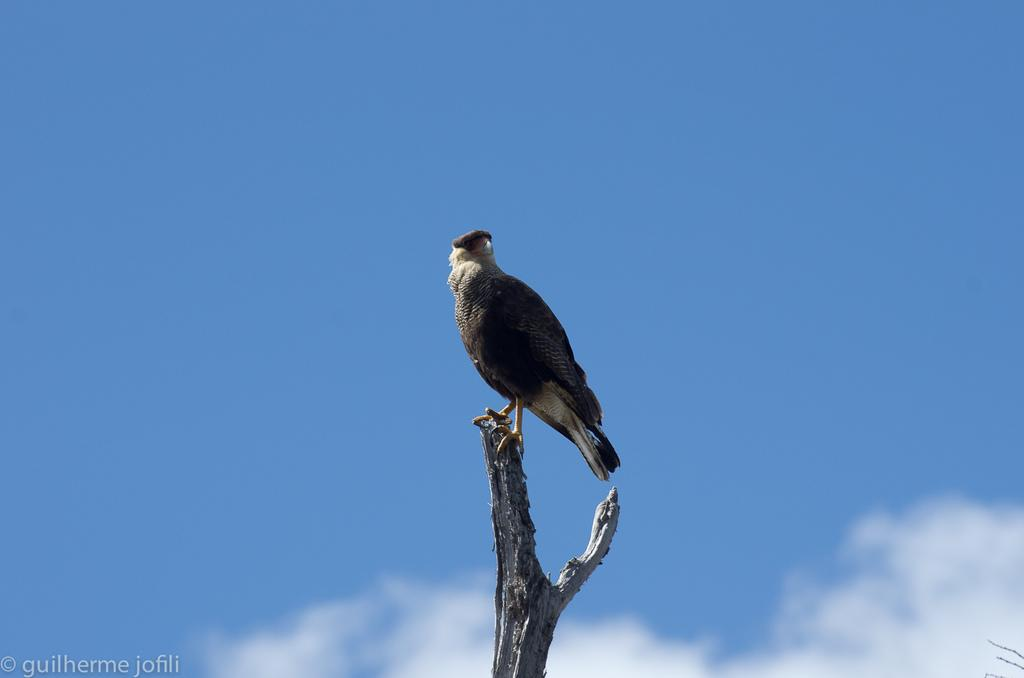What animal can be seen in the image? There is a bird in the image. Where is the bird located? The bird is standing on a tree branch. What can be seen at the top of the image? The sky is visible at the top of the image. What is present in the sky? There are clouds in the sky. What is written or depicted in the bottom left corner of the image? There is a text in the bottom left corner of the image. What is the bird's role in the ongoing battle in the image? There is no battle present in the image; it features a bird standing on a tree branch with clouds in the sky. How does the bird express its love for the other birds in the image? There is no indication of love or interaction between birds in the image; it simply shows a bird standing on a tree branch. 